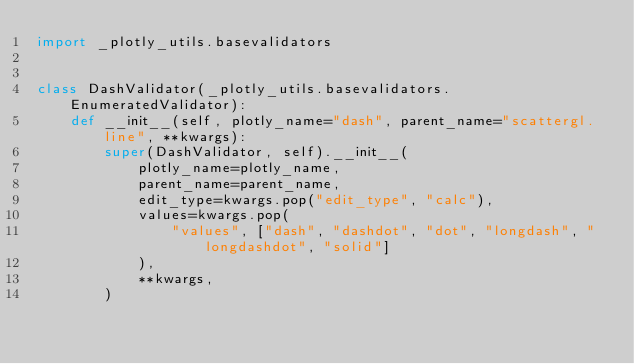Convert code to text. <code><loc_0><loc_0><loc_500><loc_500><_Python_>import _plotly_utils.basevalidators


class DashValidator(_plotly_utils.basevalidators.EnumeratedValidator):
    def __init__(self, plotly_name="dash", parent_name="scattergl.line", **kwargs):
        super(DashValidator, self).__init__(
            plotly_name=plotly_name,
            parent_name=parent_name,
            edit_type=kwargs.pop("edit_type", "calc"),
            values=kwargs.pop(
                "values", ["dash", "dashdot", "dot", "longdash", "longdashdot", "solid"]
            ),
            **kwargs,
        )
</code> 